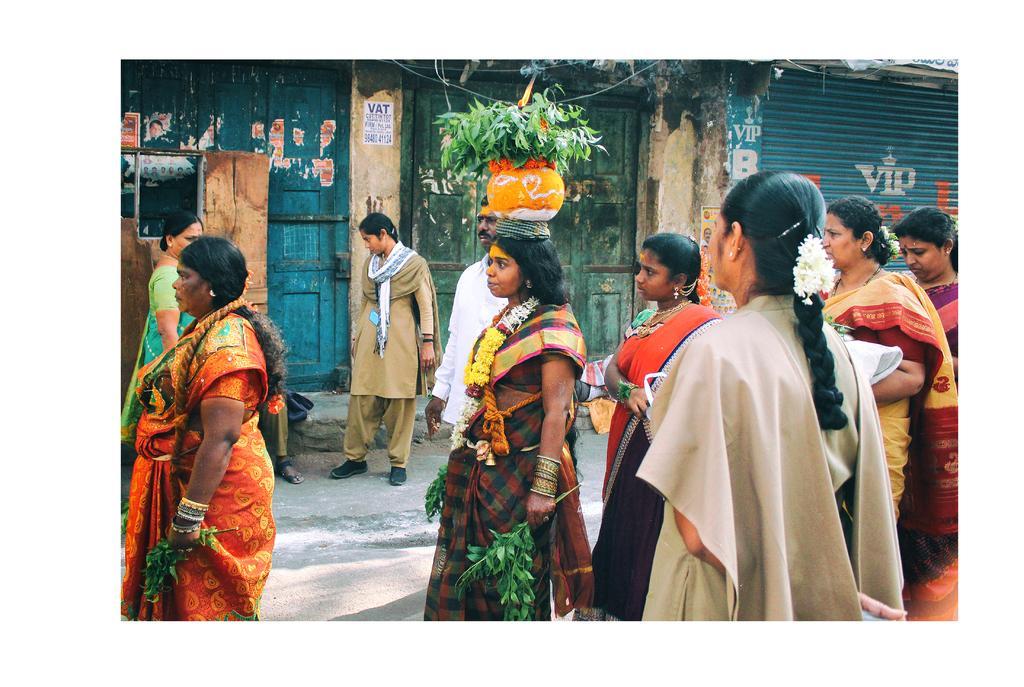How would you summarize this image in a sentence or two? In this image we can see a group of people standing on the ground. In that we can see a woman wearing a rope and garland holding some stems of neem, carrying a pot on her head containing some neem stems and a flame on it. On the left side we can see a woman holding some stems carrying a rope. On the backside we can see a building with a door and shutters. We can also see a paper with some text on it which is pasted on a wall. 